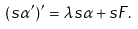<formula> <loc_0><loc_0><loc_500><loc_500>( s \alpha ^ { \prime } ) ^ { \prime } = \lambda s \alpha + s F .</formula> 